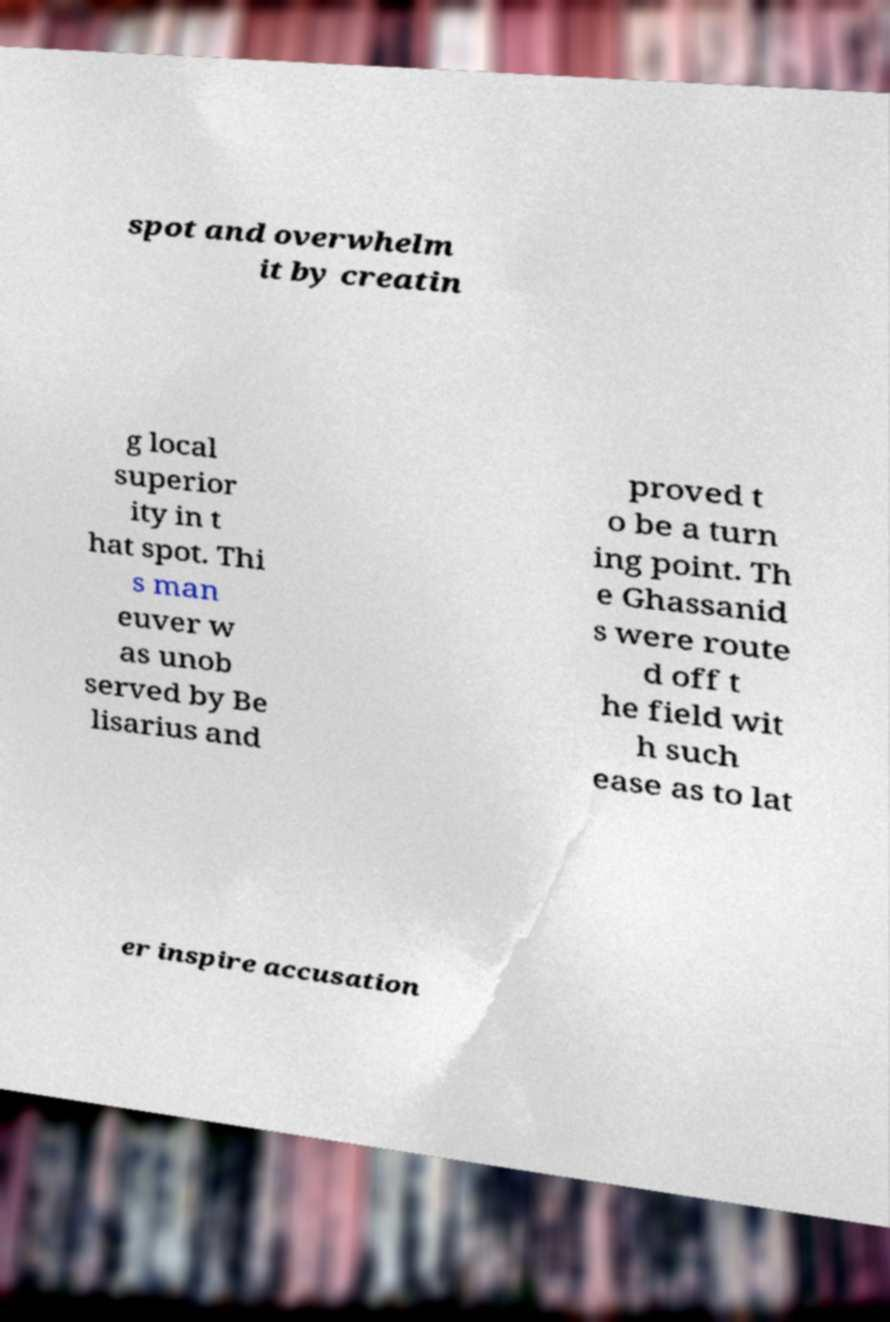For documentation purposes, I need the text within this image transcribed. Could you provide that? spot and overwhelm it by creatin g local superior ity in t hat spot. Thi s man euver w as unob served by Be lisarius and proved t o be a turn ing point. Th e Ghassanid s were route d off t he field wit h such ease as to lat er inspire accusation 